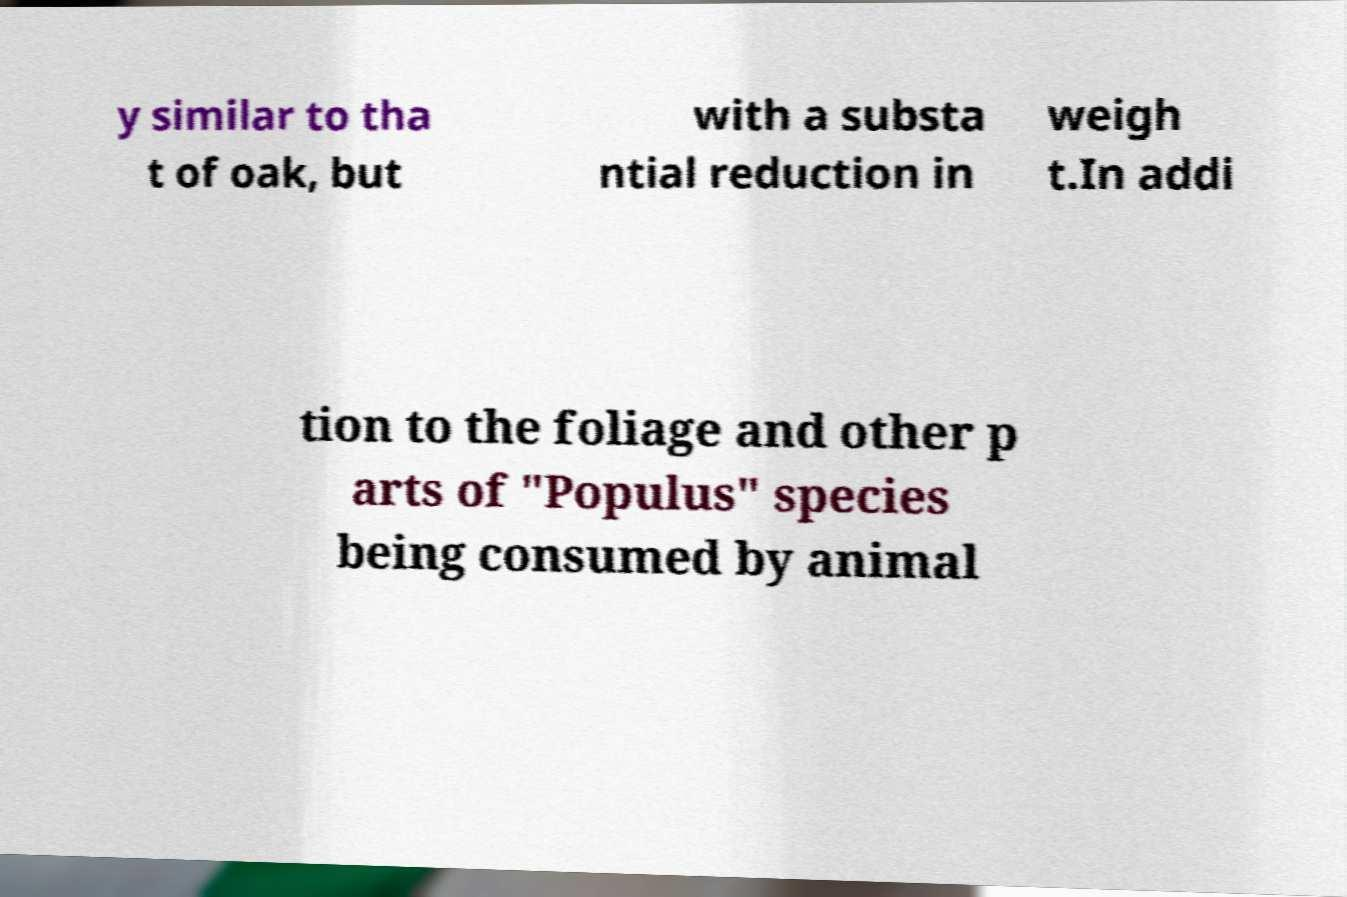Can you read and provide the text displayed in the image?This photo seems to have some interesting text. Can you extract and type it out for me? y similar to tha t of oak, but with a substa ntial reduction in weigh t.In addi tion to the foliage and other p arts of "Populus" species being consumed by animal 